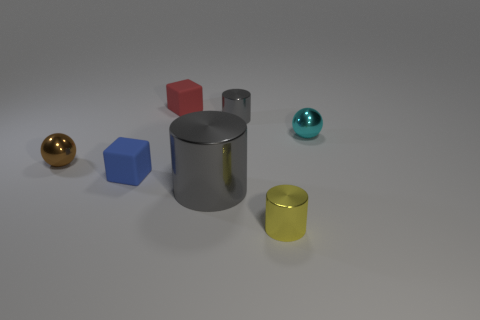How many tiny red things have the same shape as the small blue thing?
Your response must be concise. 1. There is a brown metallic thing; is its shape the same as the small cyan thing that is behind the brown thing?
Offer a terse response. Yes. There is a small yellow object; how many gray things are to the right of it?
Your answer should be very brief. 0. Is there a yellow block of the same size as the cyan shiny object?
Your answer should be compact. No. Is the shape of the brown thing behind the blue object the same as  the cyan object?
Give a very brief answer. Yes. What color is the big cylinder?
Your response must be concise. Gray. What shape is the small shiny thing that is the same color as the large cylinder?
Ensure brevity in your answer.  Cylinder. Is there a small brown matte ball?
Your answer should be compact. No. There is a yellow object that is the same material as the small brown sphere; what size is it?
Provide a succinct answer. Small. What shape is the yellow thing that is right of the small sphere to the left of the shiny ball to the right of the red rubber block?
Your response must be concise. Cylinder. 